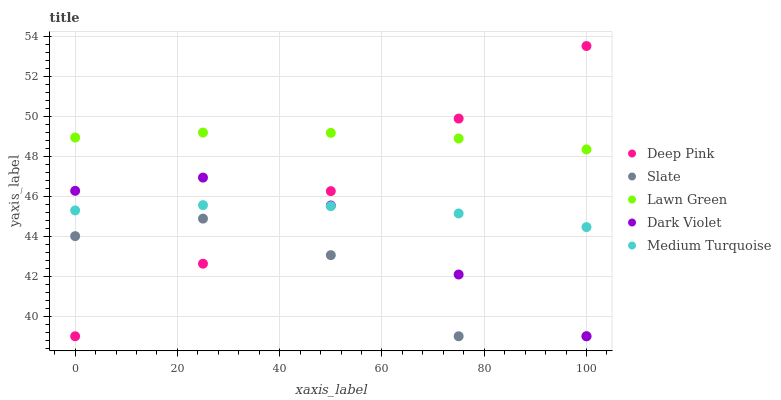Does Slate have the minimum area under the curve?
Answer yes or no. Yes. Does Lawn Green have the maximum area under the curve?
Answer yes or no. Yes. Does Deep Pink have the minimum area under the curve?
Answer yes or no. No. Does Deep Pink have the maximum area under the curve?
Answer yes or no. No. Is Deep Pink the smoothest?
Answer yes or no. Yes. Is Slate the roughest?
Answer yes or no. Yes. Is Slate the smoothest?
Answer yes or no. No. Is Deep Pink the roughest?
Answer yes or no. No. Does Slate have the lowest value?
Answer yes or no. Yes. Does Medium Turquoise have the lowest value?
Answer yes or no. No. Does Deep Pink have the highest value?
Answer yes or no. Yes. Does Slate have the highest value?
Answer yes or no. No. Is Slate less than Medium Turquoise?
Answer yes or no. Yes. Is Medium Turquoise greater than Slate?
Answer yes or no. Yes. Does Deep Pink intersect Dark Violet?
Answer yes or no. Yes. Is Deep Pink less than Dark Violet?
Answer yes or no. No. Is Deep Pink greater than Dark Violet?
Answer yes or no. No. Does Slate intersect Medium Turquoise?
Answer yes or no. No. 